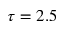<formula> <loc_0><loc_0><loc_500><loc_500>\tau = 2 . 5</formula> 